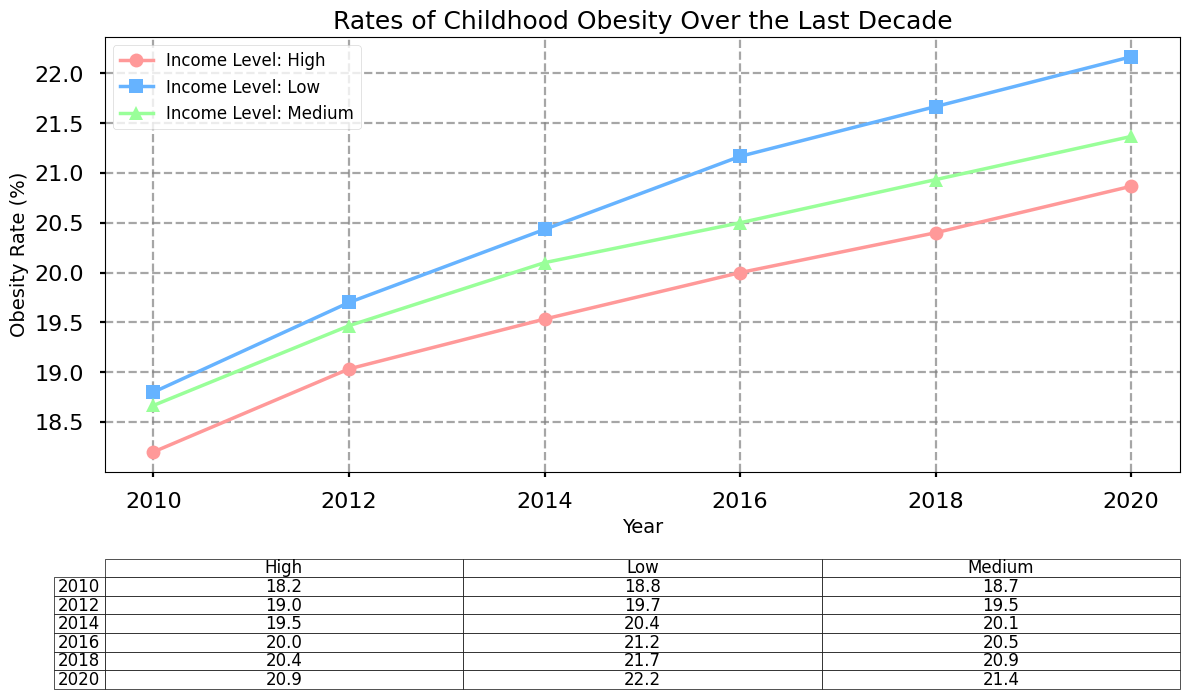What trend can be observed in childhood obesity rates for high-income levels over the decade? Looking at the line for high-income levels, it shows an upward trend, starting from approximately 18.1% in 2010 and rising to about 21.2% in 2020.
Answer: Upward trend How does the obesity rate for low-income, rural areas in 2012 compare to 2018? The rate for low-income, rural areas in 2012 is 21.1%, and in 2018 it is 23.3%, showing an increase.
Answer: Increased Which year had the highest overall obesity rate for medium-income suburban areas, and what was the rate? Looking at the line for medium-income, suburban areas, the highest rate appears in 2020 with a value of 21.5%.
Answer: 2020, 21.5% For low-income urban areas, what is the difference in obesity rates between 2010 and 2020? The rate for low-income urban areas in 2010 is 16.9%, while in 2020 it is 20.0%. The difference is 20.0% - 16.9% = 3.1%.
Answer: 3.1% What's the average obesity rate for high-income suburban areas over the years 2010, 2012, and 2014? The rates are 17.9% (2010), 18.9% (2012), and 19.3% (2014). The average is (17.9 + 18.9 + 19.3)/3 = 18.7%.
Answer: 18.7% Did medium-income rural areas experience a greater increase in obesity rates from 2010 to 2016 or from 2016 to 2020? The rate in 2010 is 19.8%, in 2016 is 21.2%, and in 2020 is 21.9%. The increase from 2010 to 2016 is 21.2% - 19.8% = 1.4%, and from 2016 to 2020 is 21.9% - 21.2% = 0.7%.
Answer: 2010 to 2016 Which income level had the least variation in obesity rates over the decade in urban areas? Inspecting the lines for all income levels in urban areas, the low-income level line has the smallest range of variation from 2010 to 2020 (from 16.9% to 20.0%). The difference is 3.1%.
Answer: Low-income level What is the combined obesity rate for high-income urban areas in 2018 and 2020? The rates are 20.5% (2018) and 21.2% (2020). The combined rate is 20.5% + 21.2% = 41.7%.
Answer: 41.7% How does the visual pattern help in comparing obesity trends among different income levels? Different markers and colors help distinguish each income level's trend line, making it easy to see that low-income levels generally show higher rates and steeper increases compared to high-income levels.
Answer: Visual markers and colors In 2014, which income level and area type combination had the highest obesity rate and what was it? In 2014, the highest obesity rate is for low-income, rural areas with a rate of 22.0%.
Answer: Low-income, rural, 22.0% 